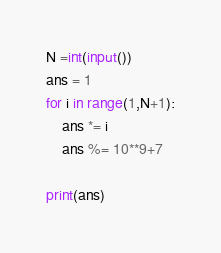Convert code to text. <code><loc_0><loc_0><loc_500><loc_500><_Python_>N =int(input())
ans = 1
for i in range(1,N+1):
    ans *= i
    ans %= 10**9+7
    
print(ans)</code> 